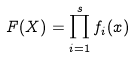<formula> <loc_0><loc_0><loc_500><loc_500>F ( X ) = \prod _ { i = 1 } ^ { s } f _ { i } ( x )</formula> 